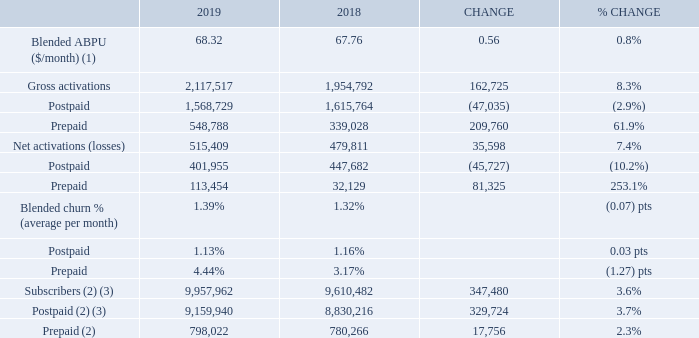BELL WIRELESS OPERATING METRICS
(1) Our Q1 2018 blended ABPU was adjusted to exclude the unfavourable retroactive impact of the CRTC decision on wireless domestic wholesale roaming rates of $14 million.
(2) At the beginning of Q1 2019, we adjusted our wireless subscriber base to remove 167,929 subscribers (72,231 postpaid and 95,698 prepaid) as follows: (A) 65,798 subscribers (19,195 postpaid and 46,603 prepaid), due to the completion of the shutdown of the CDMA network on April 30, 2019, (B) 49,095 prepaid subscribers as a result of a change to our deactivation policy, mainly from 120 days for Bell/Virgin Mobile and 150 days for Lucky Mobile to 90 days, (C) 43,670 postpaid subscribers relating to IoT due to the further refinement of our subscriber definition as a result of technology evolution, and (D) 9,366 postpaid fixed wireless Internet subscribers which were transferred to our retail high-speed Internet subscriber base.
(3) At the beginning of Q4 2018, we adjusted our postpaid wireless subscriber base to remove 20,000 subscribers that we divested to Xplornet as a result of BCE’s acquisition of MTS in 2017.
Blended ABPU of $68.32 increased by 0.8% in 2019, compared to 2018, driven by: • A greater mix of customers subscribing to higher-value monthly plans including unlimited data plans • The flow-through of rate increases • The favourable impact from the subscriber base adjustments performed in Q1 2019
These factors were partly offset by: • Lower data and voice overages driven by increased customer adoption of monthly plans with higher data allotments and richer voice plans • Lower ABPU generated from our long-term mobile services contract with Shared Services Canada (SSC) • The dilutive impact from the continued growth in prepaid customers driven by Lucky Mobile, our low-cost prepaid mobile service
Total gross wireless activations increased by 8.3% in 2019, compared to last year, due to higher prepaid gross activations, offset in part by lower postpaid gross activations. • Postpaid gross activations decreased by 2.9% in 2019, compared to 2018, mainly due to fewer year-over-year customer additions from our contract with SSC as the migration process is essentially complete. Excluding the impact of the SSC contract, postpaid gross activations were higher year over year, driven by our mobile network quality, strong sales execution and focus on subscriber base management. • Prepaid gross activations increased by 61.9% in 2019, compared to last year, driven by the continued growth from Lucky Mobile along with the benefit from the national retail distribution of Lucky Mobile and Virgin Mobile prepaid services at Dollarama stores
Blended wireless churn of 1.39% increased by 0.07 pts in 2019, compared to 2018. • Postpaid churn of 1.13% improved by 0.03 pts in 2019, compared to last year, driven by the favourable impact from our ongoing investments in customer retention and network speeds • Prepaid churn of 4.44% increased by 1.27 pts in 2019, compared to the prior year, due to greater competitive intensity in the discount mobile market and the impact from the harmonization of our prepaid deactivation policy across all Bell Wireless brands from 120 days for Bell and Virgin Mobile and 150 days for Lucky Mobile to 90 days
Net activations grew by 7.4% in 2019, compared to 2018, due to higher prepaid net activations, moderated by lower postpaid net activations. • Postpaid net activations decreased by 10.2% in 2019, compared to 2018, driven by lower gross activations • Prepaid net activations increased by 81,325 in 2019, compared to last year, due to higher gross activations, offset in part by greater customer deactivations
Wireless subscribers at December 31, 2019 totaled 9,957,962, an increase of 3.6% from 9,610,482 subscribers reported at the end of 2018. This was comprised of 9,159,940 postpaid subscribers and 798,022 prepaid subscribers, an increase of 3.7% and 2.3%, respectively, year over year. At the end of 2019, the proportion of Bell Wireless customers subscribing to our postpaid service was stable at 92%, compared to last year. At the beginning of Q1 2019, we adjusted our wireless subscriber base to remove 167,929 subscribers (72,231 postpaid and 95,698 prepaid) as follows: • 65,798 subscribers (19,195 postpaid and 46,603 prepaid), due to the completion of the shutdown of the CDMA network on April 30, 2019 • 49,095 prepaid subscribers as a result of a change to our deactivation policy, mainly from 120 days for Bell/Virgin Mobile and 150 days for Lucky Mobile to 90 days • 43,670 postpaid subscribers relating to IoT due to the further refinement of our subscriber definition as a result of the technology evolution • 9,366 postpaid fixed wireless Internet subscribers which were transferred to our retail high-speed Internet subscriber base
What was excluded in the Q1 2018 blended ABPU? The unfavourable retroactive impact of the crtc decision on wireless domestic wholesale roaming rates of $14 million. How many subscribers were removed when the postpaid wireless subscriber base was adjusted at the beginning of Q4 2018? 20,000. What is the blended ABPU ($/month) in 2019? 68.32. What is the total amount of gross activations for prepaid in 2019 and 2018? 548,788+339,028
Answer: 887816. What is the percentage of postpaid in the net activations in 2019?
Answer scale should be: percent. 401,955/515,409
Answer: 77.99. What is the Blended ABPU rate per year for 2019? 68.32*12
Answer: 819.84. 